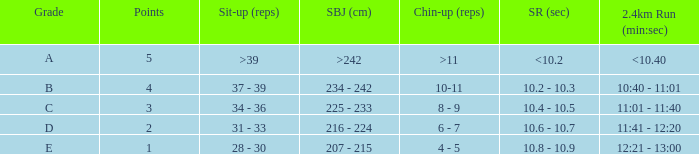Tell me the shuttle run with grade c 10.4 - 10.5. 